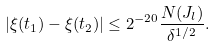<formula> <loc_0><loc_0><loc_500><loc_500>| \xi ( t _ { 1 } ) - \xi ( t _ { 2 } ) | \leq 2 ^ { - 2 0 } \frac { N ( J _ { l } ) } { \delta ^ { 1 / 2 } } .</formula> 